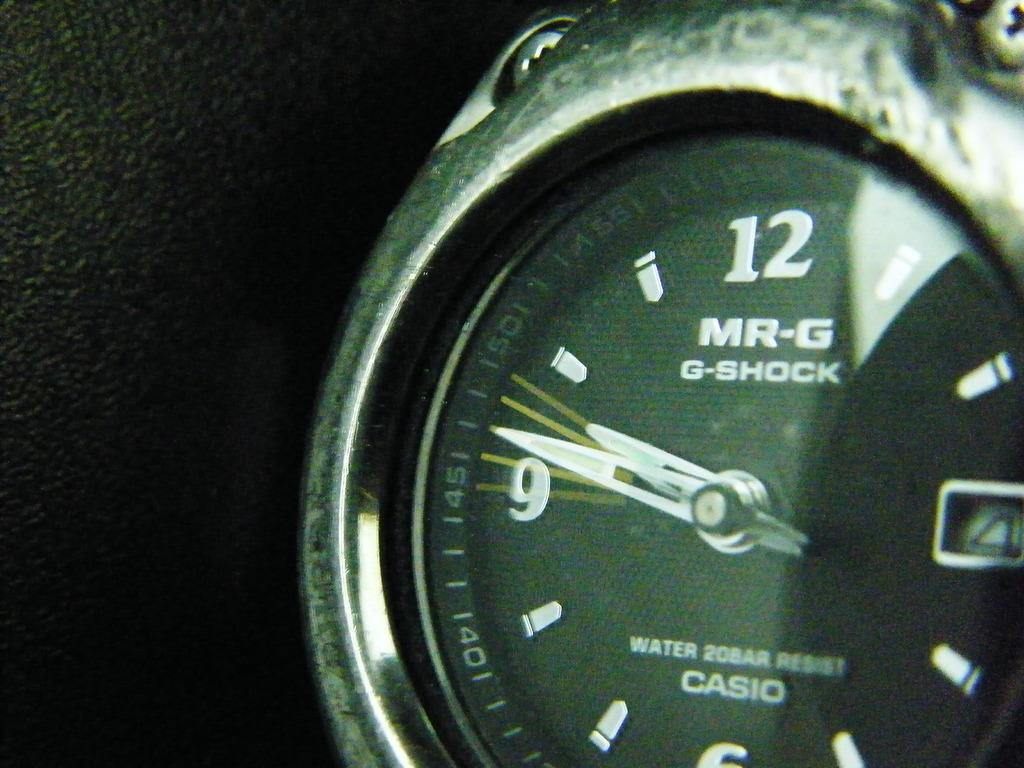Provide a one-sentence caption for the provided image. A face of a MR-G G-Shock Water 20Bar Resist Casio watch with time of 9:47. 